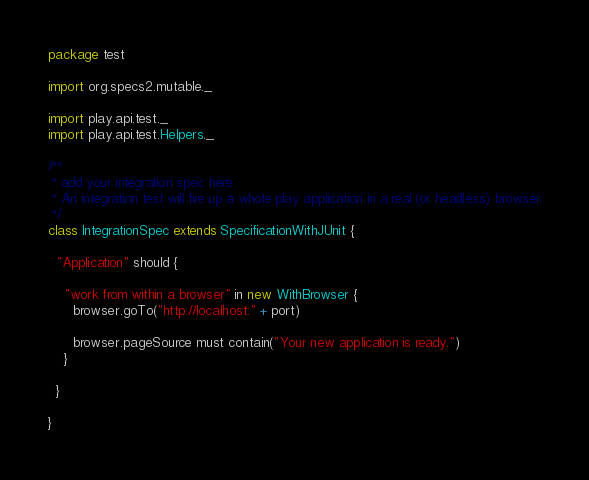<code> <loc_0><loc_0><loc_500><loc_500><_Scala_>package test

import org.specs2.mutable._

import play.api.test._
import play.api.test.Helpers._

/**
 * add your integration spec here.
 * An integration test will fire up a whole play application in a real (or headless) browser
 */
class IntegrationSpec extends SpecificationWithJUnit {

  "Application" should {

    "work from within a browser" in new WithBrowser {
      browser.goTo("http://localhost:" + port)

      browser.pageSource must contain("Your new application is ready.")
    }

  }

}</code> 